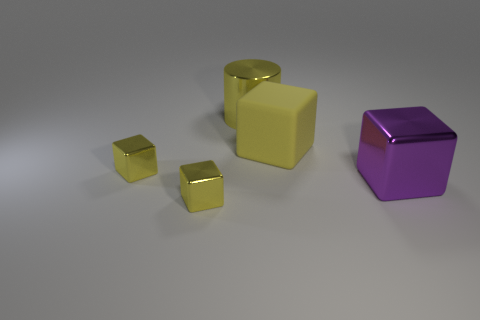Subtract all yellow cubes. How many were subtracted if there are1yellow cubes left? 2 Subtract all purple cylinders. How many yellow cubes are left? 3 Add 1 large metallic blocks. How many objects exist? 6 Subtract all cubes. How many objects are left? 1 Subtract all tiny yellow metal cubes. Subtract all yellow matte cubes. How many objects are left? 2 Add 3 large purple shiny blocks. How many large purple shiny blocks are left? 4 Add 3 large cubes. How many large cubes exist? 5 Subtract 0 yellow balls. How many objects are left? 5 